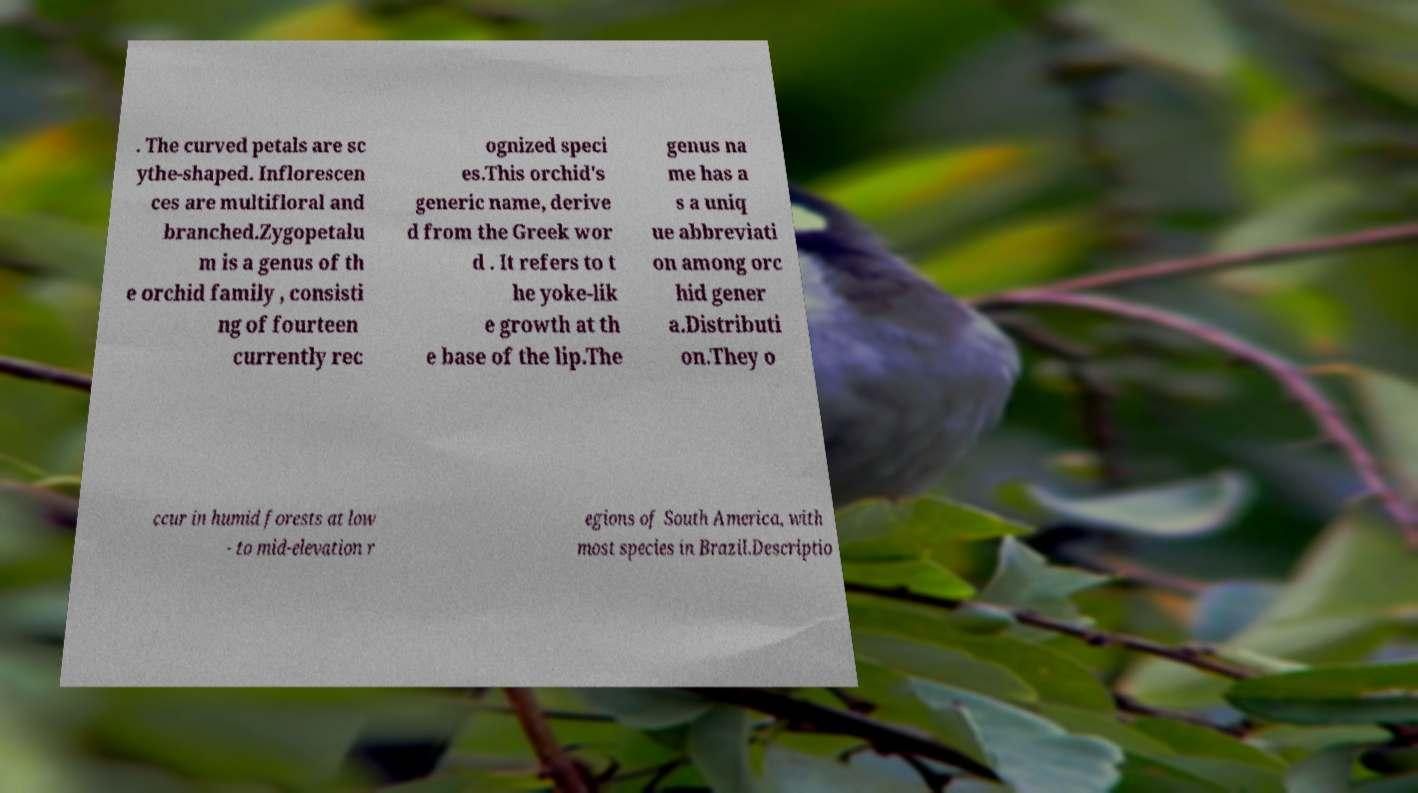Could you extract and type out the text from this image? . The curved petals are sc ythe-shaped. Inflorescen ces are multifloral and branched.Zygopetalu m is a genus of th e orchid family , consisti ng of fourteen currently rec ognized speci es.This orchid's generic name, derive d from the Greek wor d . It refers to t he yoke-lik e growth at th e base of the lip.The genus na me has a s a uniq ue abbreviati on among orc hid gener a.Distributi on.They o ccur in humid forests at low - to mid-elevation r egions of South America, with most species in Brazil.Descriptio 